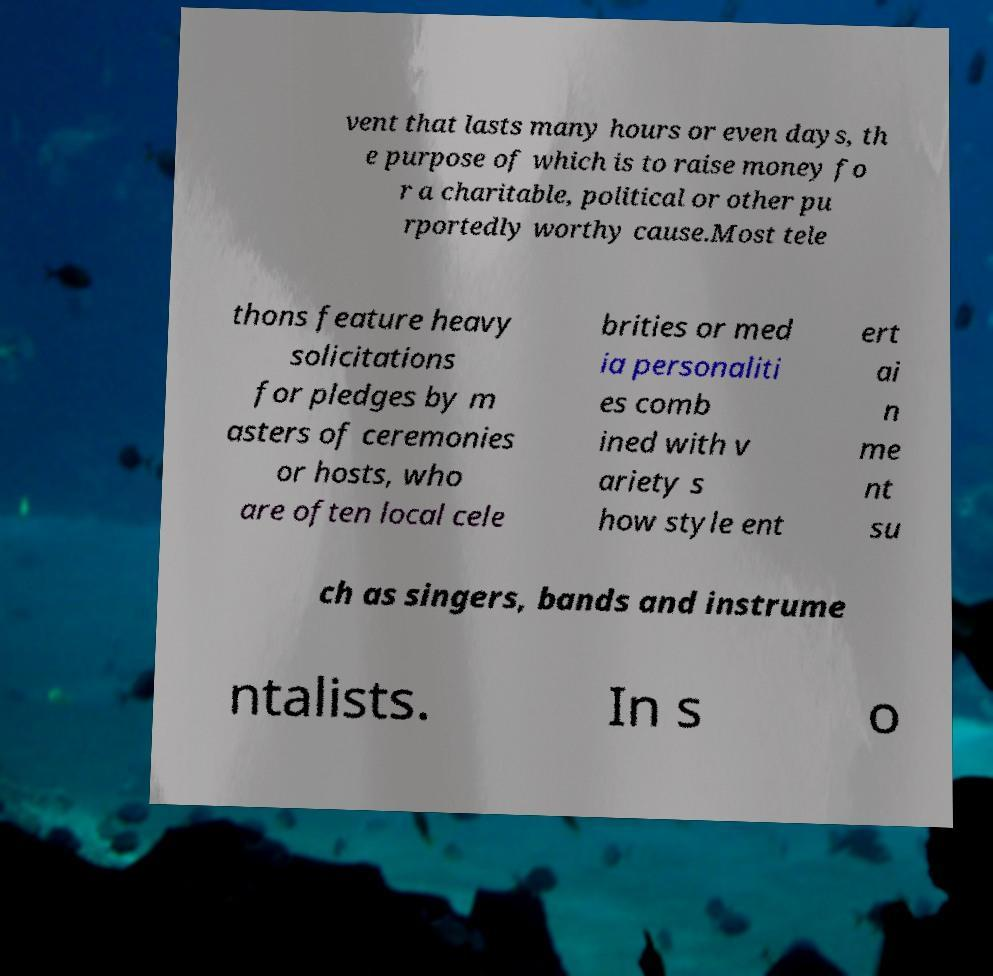What messages or text are displayed in this image? I need them in a readable, typed format. vent that lasts many hours or even days, th e purpose of which is to raise money fo r a charitable, political or other pu rportedly worthy cause.Most tele thons feature heavy solicitations for pledges by m asters of ceremonies or hosts, who are often local cele brities or med ia personaliti es comb ined with v ariety s how style ent ert ai n me nt su ch as singers, bands and instrume ntalists. In s o 